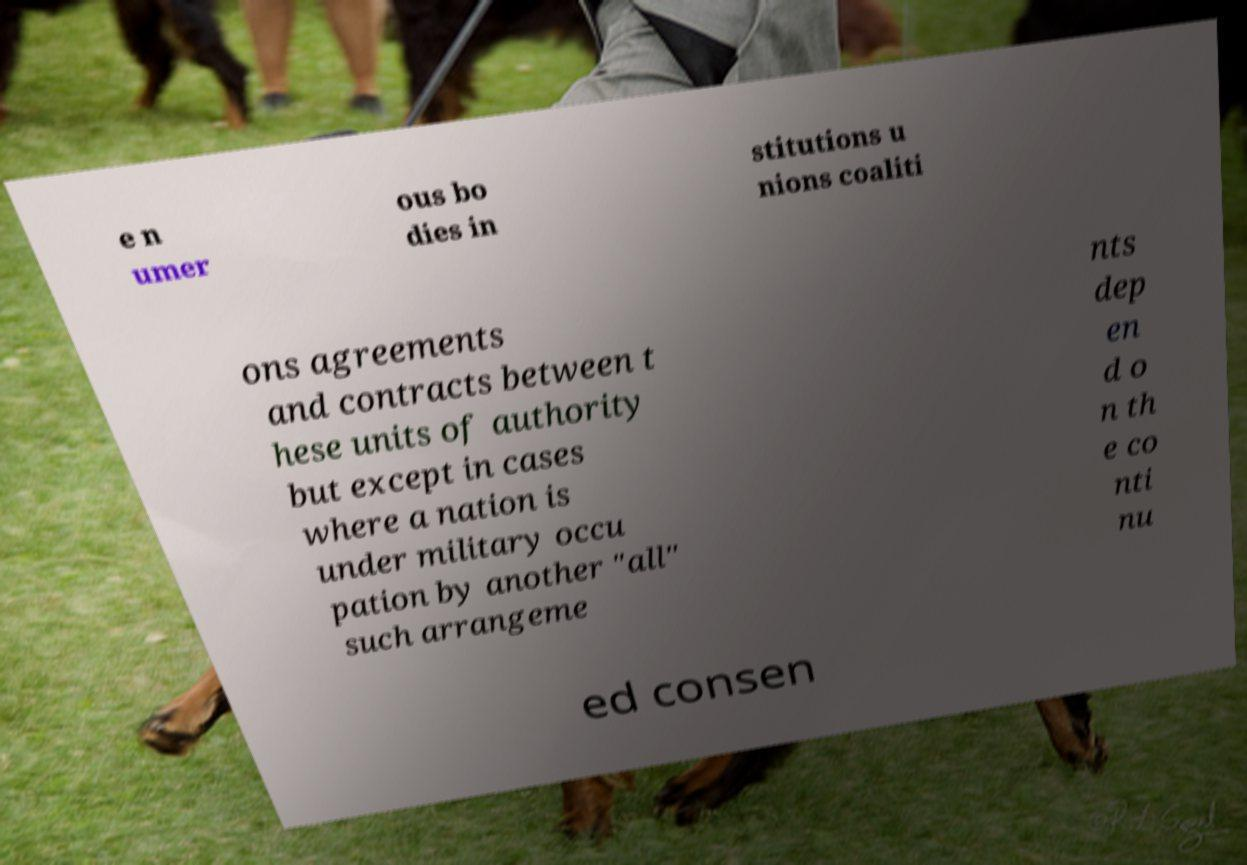For documentation purposes, I need the text within this image transcribed. Could you provide that? e n umer ous bo dies in stitutions u nions coaliti ons agreements and contracts between t hese units of authority but except in cases where a nation is under military occu pation by another "all" such arrangeme nts dep en d o n th e co nti nu ed consen 